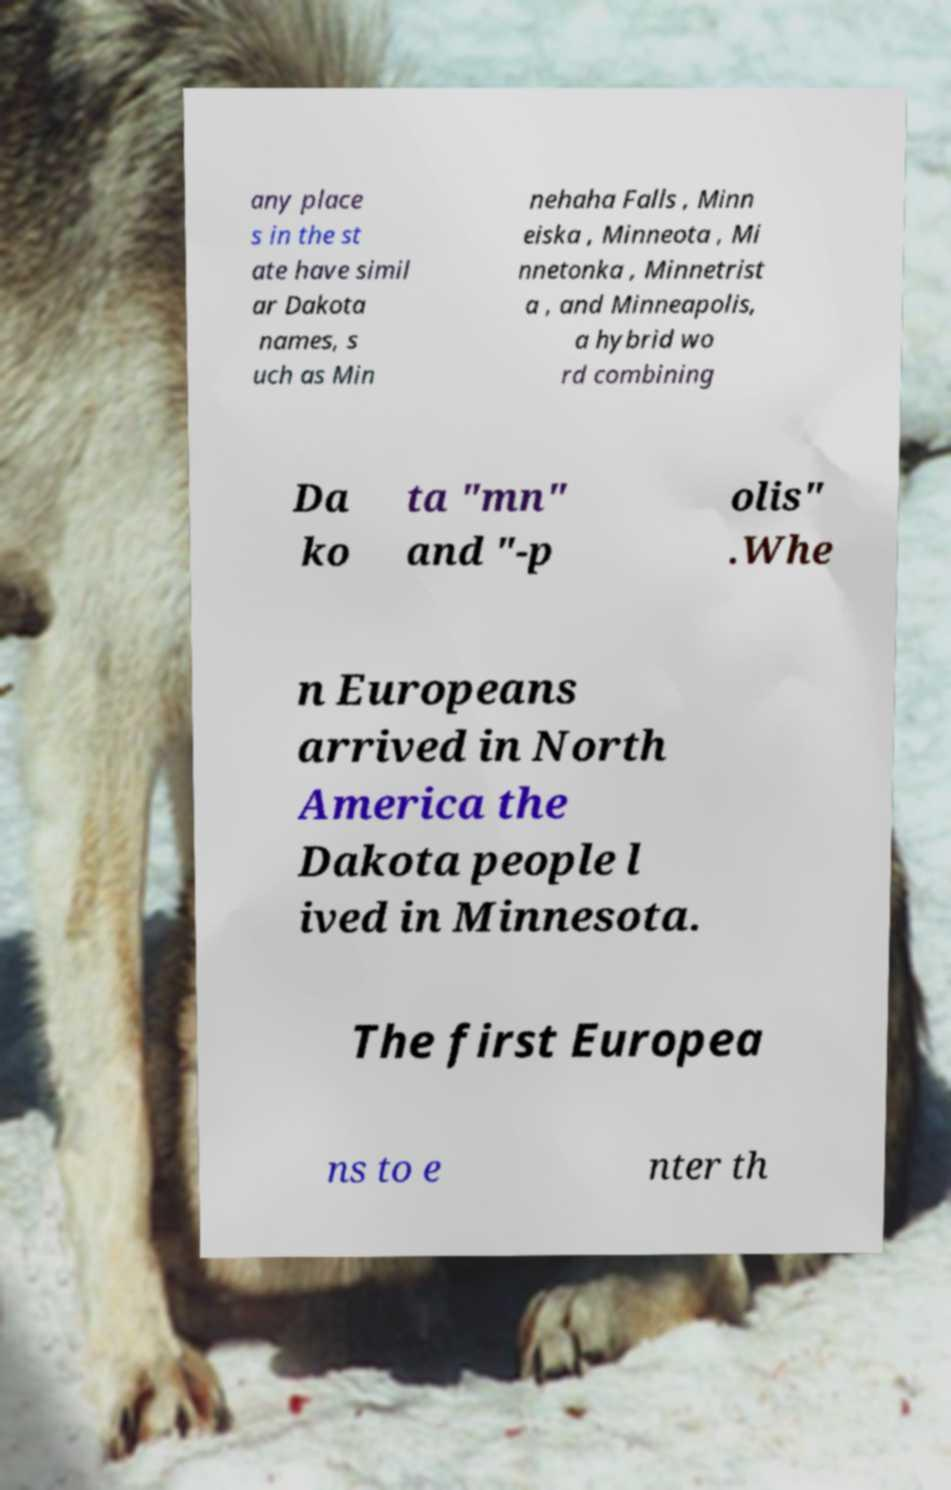Could you assist in decoding the text presented in this image and type it out clearly? any place s in the st ate have simil ar Dakota names, s uch as Min nehaha Falls , Minn eiska , Minneota , Mi nnetonka , Minnetrist a , and Minneapolis, a hybrid wo rd combining Da ko ta "mn" and "-p olis" .Whe n Europeans arrived in North America the Dakota people l ived in Minnesota. The first Europea ns to e nter th 